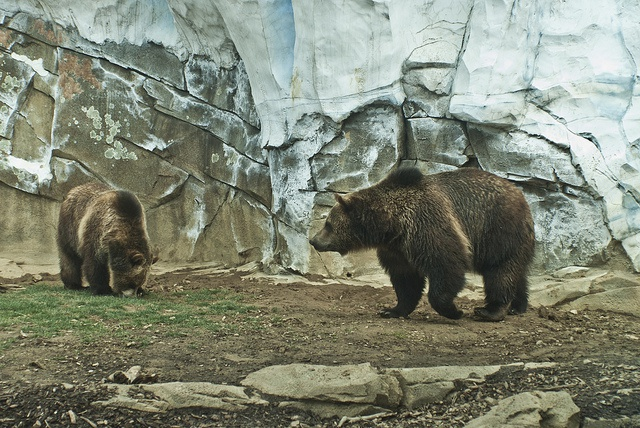Describe the objects in this image and their specific colors. I can see bear in darkgray, black, and gray tones and bear in darkgray, black, and gray tones in this image. 